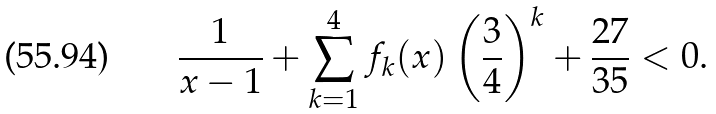<formula> <loc_0><loc_0><loc_500><loc_500>\frac { 1 } { x - 1 } + \sum _ { k = 1 } ^ { 4 } f _ { k } ( x ) \left ( \frac { 3 } { 4 } \right ) ^ { k } + \frac { 2 7 } { 3 5 } < 0 .</formula> 